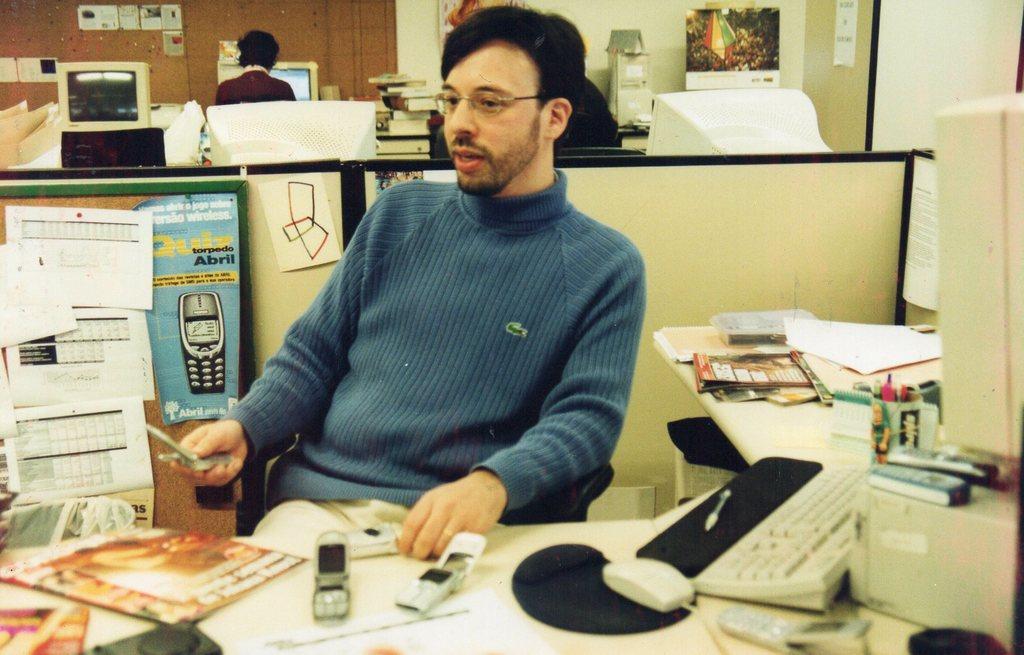How would you summarize this image in a sentence or two? In the picture we can see man sitting on a chair near the desk. On the desk we can find monitor, keyboard, keyboard, mouse, mouse pad, two mobile phones, and papers. In the background we can find monitor some person sitting near the monitor and a wall. 